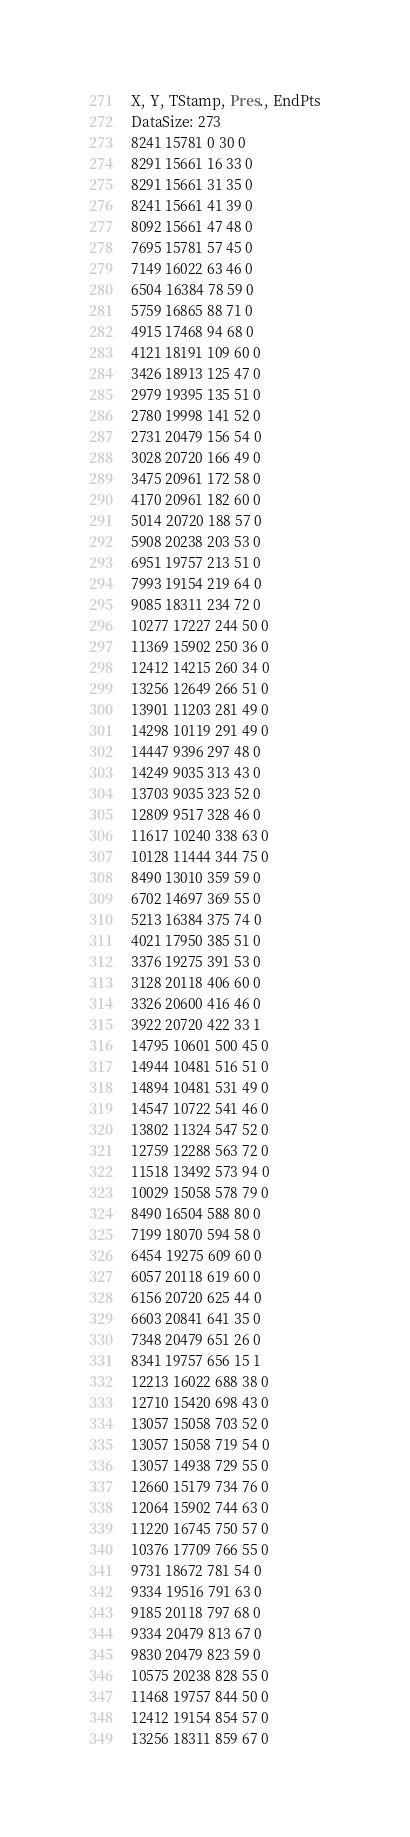Convert code to text. <code><loc_0><loc_0><loc_500><loc_500><_SML_>X, Y, TStamp, Pres., EndPts
DataSize: 273
8241 15781 0 30 0
8291 15661 16 33 0
8291 15661 31 35 0
8241 15661 41 39 0
8092 15661 47 48 0
7695 15781 57 45 0
7149 16022 63 46 0
6504 16384 78 59 0
5759 16865 88 71 0
4915 17468 94 68 0
4121 18191 109 60 0
3426 18913 125 47 0
2979 19395 135 51 0
2780 19998 141 52 0
2731 20479 156 54 0
3028 20720 166 49 0
3475 20961 172 58 0
4170 20961 182 60 0
5014 20720 188 57 0
5908 20238 203 53 0
6951 19757 213 51 0
7993 19154 219 64 0
9085 18311 234 72 0
10277 17227 244 50 0
11369 15902 250 36 0
12412 14215 260 34 0
13256 12649 266 51 0
13901 11203 281 49 0
14298 10119 291 49 0
14447 9396 297 48 0
14249 9035 313 43 0
13703 9035 323 52 0
12809 9517 328 46 0
11617 10240 338 63 0
10128 11444 344 75 0
8490 13010 359 59 0
6702 14697 369 55 0
5213 16384 375 74 0
4021 17950 385 51 0
3376 19275 391 53 0
3128 20118 406 60 0
3326 20600 416 46 0
3922 20720 422 33 1
14795 10601 500 45 0
14944 10481 516 51 0
14894 10481 531 49 0
14547 10722 541 46 0
13802 11324 547 52 0
12759 12288 563 72 0
11518 13492 573 94 0
10029 15058 578 79 0
8490 16504 588 80 0
7199 18070 594 58 0
6454 19275 609 60 0
6057 20118 619 60 0
6156 20720 625 44 0
6603 20841 641 35 0
7348 20479 651 26 0
8341 19757 656 15 1
12213 16022 688 38 0
12710 15420 698 43 0
13057 15058 703 52 0
13057 15058 719 54 0
13057 14938 729 55 0
12660 15179 734 76 0
12064 15902 744 63 0
11220 16745 750 57 0
10376 17709 766 55 0
9731 18672 781 54 0
9334 19516 791 63 0
9185 20118 797 68 0
9334 20479 813 67 0
9830 20479 823 59 0
10575 20238 828 55 0
11468 19757 844 50 0
12412 19154 854 57 0
13256 18311 859 67 0</code> 